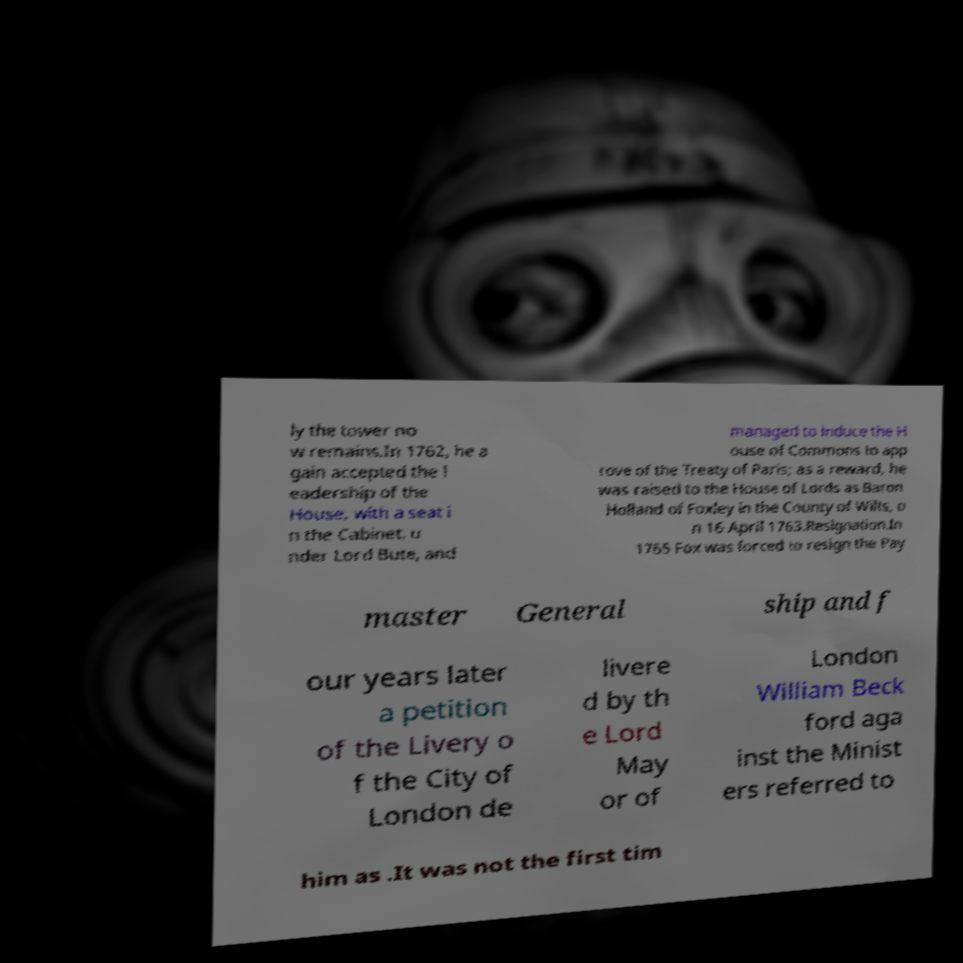Could you assist in decoding the text presented in this image and type it out clearly? ly the tower no w remains.In 1762, he a gain accepted the l eadership of the House, with a seat i n the Cabinet, u nder Lord Bute, and managed to induce the H ouse of Commons to app rove of the Treaty of Paris; as a reward, he was raised to the House of Lords as Baron Holland of Foxley in the County of Wilts, o n 16 April 1763.Resignation.In 1765 Fox was forced to resign the Pay master General ship and f our years later a petition of the Livery o f the City of London de livere d by th e Lord May or of London William Beck ford aga inst the Minist ers referred to him as .It was not the first tim 